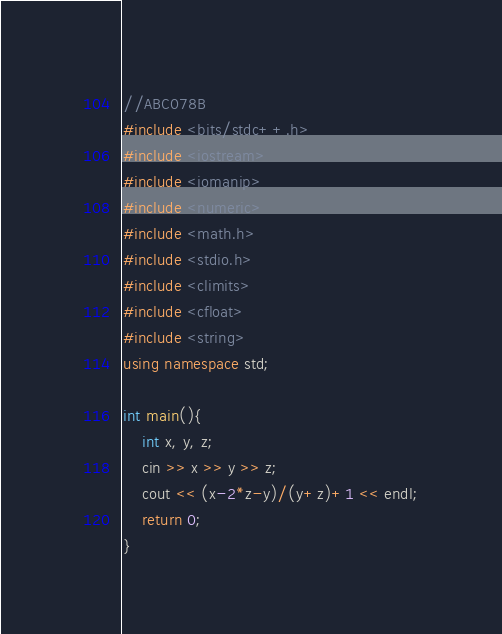<code> <loc_0><loc_0><loc_500><loc_500><_C++_>//ABC078B
#include <bits/stdc++.h>
#include <iostream>
#include <iomanip>
#include <numeric>
#include <math.h>
#include <stdio.h>
#include <climits>
#include <cfloat>
#include <string>
using namespace std;

int main(){
	int x, y, z;
	cin >> x >> y >> z;
	cout << (x-2*z-y)/(y+z)+1 << endl;
	return 0;
}</code> 